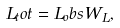Convert formula to latex. <formula><loc_0><loc_0><loc_500><loc_500>L _ { t } o t = L _ { o } b s W _ { L } ,</formula> 